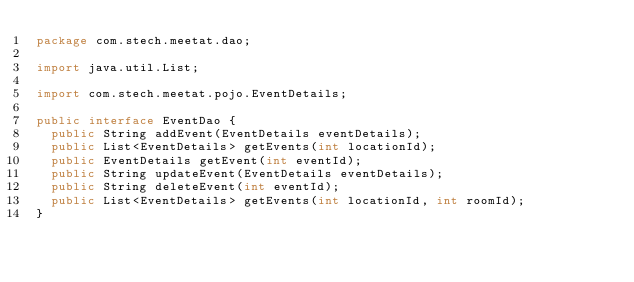Convert code to text. <code><loc_0><loc_0><loc_500><loc_500><_Java_>package com.stech.meetat.dao;

import java.util.List;

import com.stech.meetat.pojo.EventDetails;

public interface EventDao {
	public String addEvent(EventDetails eventDetails);
	public List<EventDetails> getEvents(int locationId);
	public EventDetails getEvent(int eventId);
	public String updateEvent(EventDetails eventDetails);
	public String deleteEvent(int eventId);
	public List<EventDetails> getEvents(int locationId, int roomId);
}
</code> 